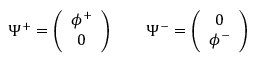<formula> <loc_0><loc_0><loc_500><loc_500>\Psi ^ { + } = \left ( \begin{array} { c } { { \phi ^ { + } } } \\ { 0 } \end{array} \right ) \quad \Psi ^ { - } = \left ( \begin{array} { c } { 0 } \\ { { \phi ^ { - } } } \end{array} \right )</formula> 